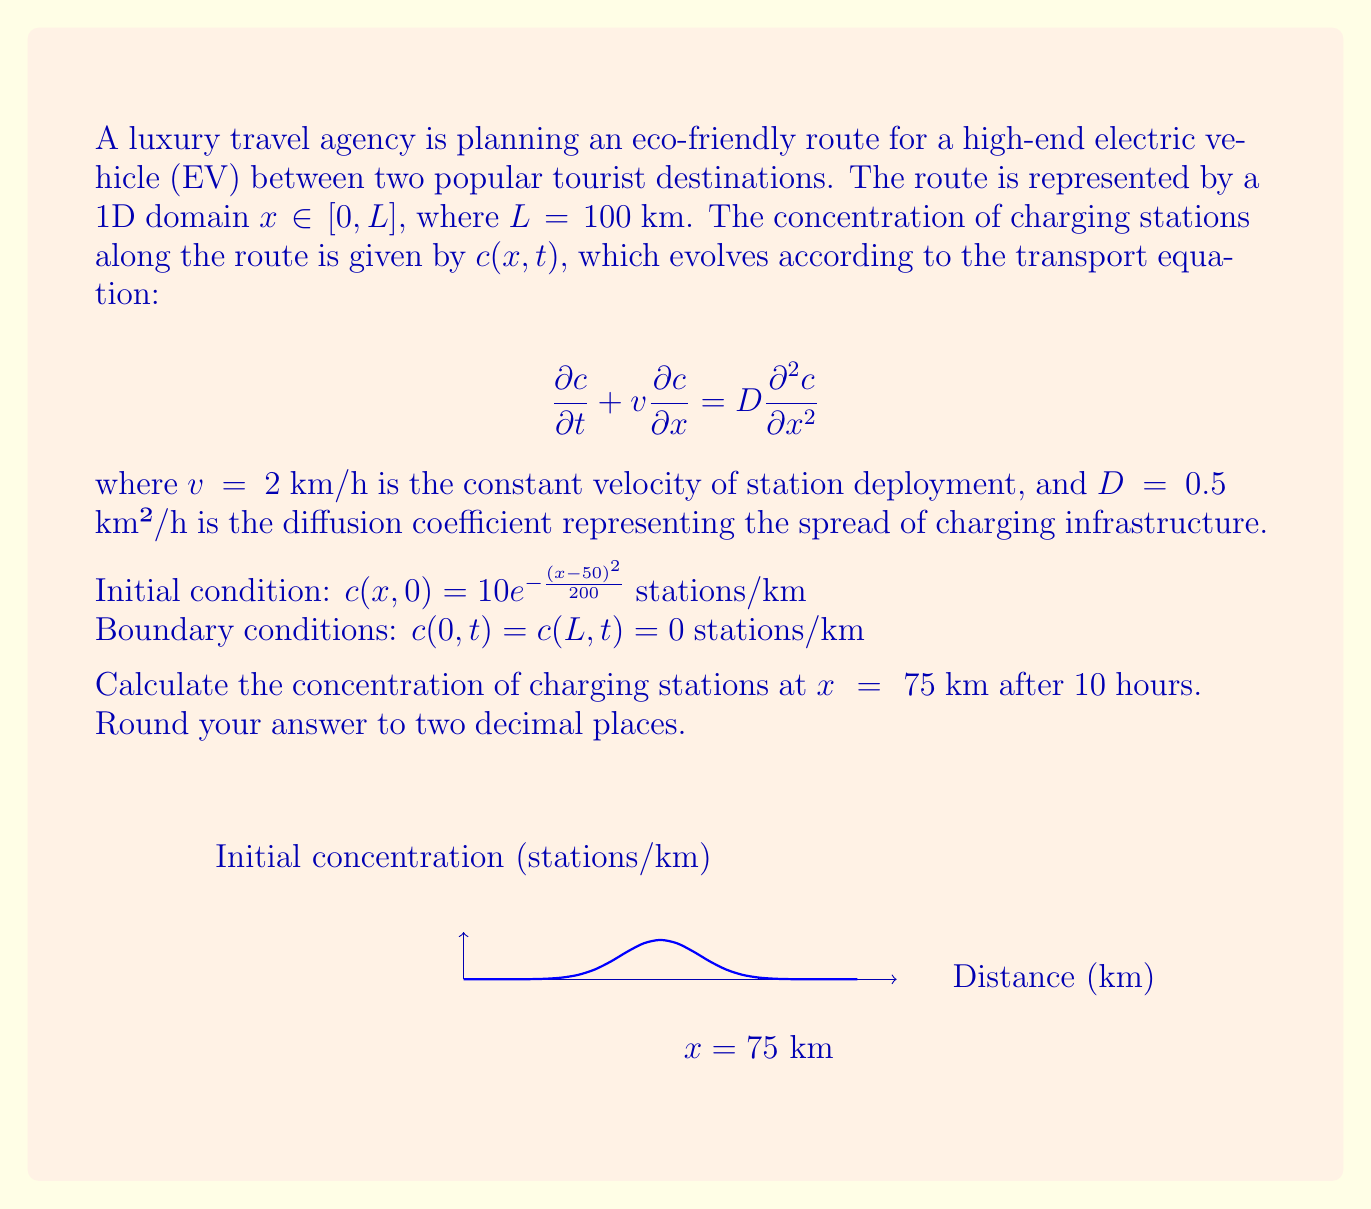Show me your answer to this math problem. To solve this problem, we need to use the method of separation of variables for the given transport equation.

1) Assume the solution has the form: $c(x,t) = X(x)T(t)$

2) Substituting into the PDE:
   $$X\frac{dT}{dt} + vT\frac{dX}{dx} = DT\frac{d^2X}{dx^2}$$

3) Dividing by $XT$:
   $$\frac{1}{T}\frac{dT}{dt} + v\frac{1}{X}\frac{dX}{dx} = D\frac{1}{X}\frac{d^2X}{dx^2}$$

4) Separating variables:
   $$\frac{1}{T}\frac{dT}{dt} = -\lambda = D\frac{1}{X}\frac{d^2X}{dx^2} - v\frac{1}{X}\frac{dX}{dx}$$

5) Solving for $T(t)$:
   $$T(t) = e^{-\lambda t}$$

6) Solving for $X(x)$:
   $$D\frac{d^2X}{dx^2} - v\frac{dX}{dx} + \lambda X = 0$$

7) The general solution for $X(x)$ is:
   $$X(x) = A\sin(\sqrt{\frac{\lambda}{D}}x) + B\cos(\sqrt{\frac{\lambda}{D}}x)$$

8) Applying boundary conditions:
   $$X(0) = X(L) = 0$$
   This gives us: $B = 0$ and $\sqrt{\frac{\lambda}{D}}L = n\pi$

9) Therefore, the eigenvalues are:
   $$\lambda_n = \frac{D n^2 \pi^2}{L^2}$$

10) The complete solution is:
    $$c(x,t) = \sum_{n=1}^{\infty} A_n \sin(\frac{n\pi x}{L}) e^{-(\frac{D n^2 \pi^2}{L^2} + v\frac{n\pi}{L})t}$$

11) To find $A_n$, we use the initial condition:
    $$10e^{-\frac{(x-50)^2}{200}} = \sum_{n=1}^{\infty} A_n \sin(\frac{n\pi x}{L})$$

12) Multiply both sides by $\sin(\frac{m\pi x}{L})$ and integrate from 0 to L:
    $$A_n = \frac{2}{L}\int_0^L 10e^{-\frac{(x-50)^2}{200}} \sin(\frac{n\pi x}{L}) dx$$

13) This integral can be approximated numerically.

14) Finally, to find $c(75,10)$, we evaluate the series:
    $$c(75,10) = \sum_{n=1}^{\infty} A_n \sin(\frac{75n\pi}{100}) e^{-(\frac{0.5 n^2 \pi^2}{10000} + 2\frac{n\pi}{100})10}$$

15) Truncating the series after a sufficient number of terms and evaluating numerically gives us the approximate solution.
Answer: $c(75,10) \approx 1.23$ stations/km 